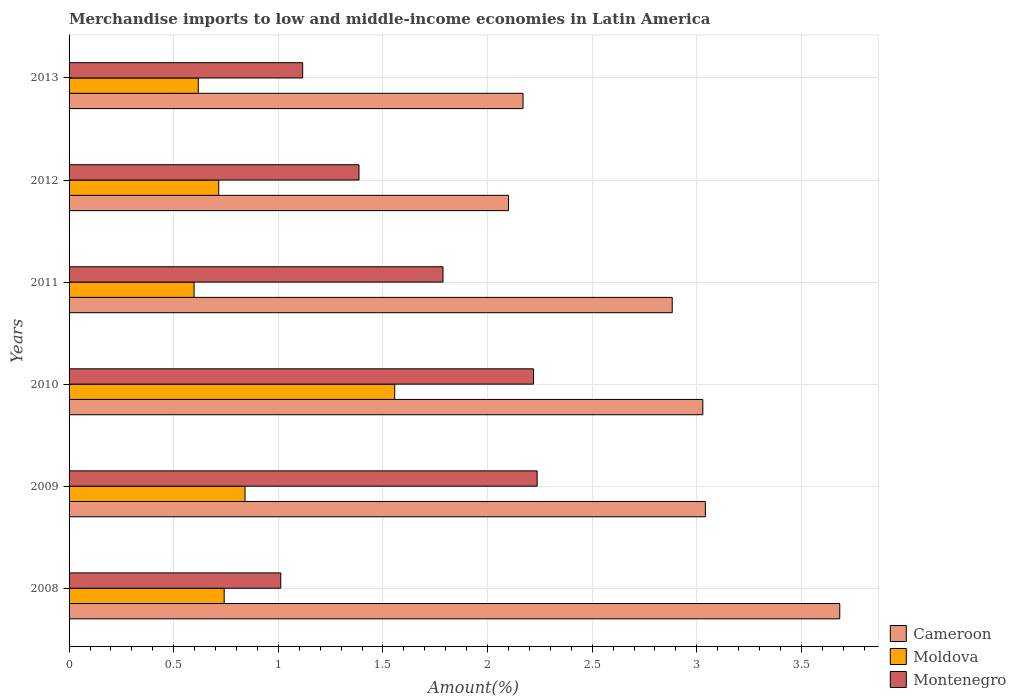How many different coloured bars are there?
Your answer should be compact. 3. How many groups of bars are there?
Ensure brevity in your answer.  6. Are the number of bars on each tick of the Y-axis equal?
Provide a succinct answer. Yes. How many bars are there on the 1st tick from the bottom?
Provide a short and direct response. 3. What is the label of the 3rd group of bars from the top?
Make the answer very short. 2011. In how many cases, is the number of bars for a given year not equal to the number of legend labels?
Your answer should be compact. 0. What is the percentage of amount earned from merchandise imports in Moldova in 2008?
Ensure brevity in your answer.  0.74. Across all years, what is the maximum percentage of amount earned from merchandise imports in Cameroon?
Make the answer very short. 3.68. Across all years, what is the minimum percentage of amount earned from merchandise imports in Montenegro?
Ensure brevity in your answer.  1.01. In which year was the percentage of amount earned from merchandise imports in Cameroon maximum?
Provide a short and direct response. 2008. What is the total percentage of amount earned from merchandise imports in Montenegro in the graph?
Keep it short and to the point. 9.76. What is the difference between the percentage of amount earned from merchandise imports in Moldova in 2011 and that in 2013?
Make the answer very short. -0.02. What is the difference between the percentage of amount earned from merchandise imports in Montenegro in 2013 and the percentage of amount earned from merchandise imports in Cameroon in 2012?
Offer a very short reply. -0.98. What is the average percentage of amount earned from merchandise imports in Moldova per year?
Your response must be concise. 0.84. In the year 2010, what is the difference between the percentage of amount earned from merchandise imports in Montenegro and percentage of amount earned from merchandise imports in Cameroon?
Provide a short and direct response. -0.81. What is the ratio of the percentage of amount earned from merchandise imports in Cameroon in 2008 to that in 2009?
Offer a very short reply. 1.21. What is the difference between the highest and the second highest percentage of amount earned from merchandise imports in Cameroon?
Make the answer very short. 0.64. What is the difference between the highest and the lowest percentage of amount earned from merchandise imports in Montenegro?
Your answer should be compact. 1.23. In how many years, is the percentage of amount earned from merchandise imports in Cameroon greater than the average percentage of amount earned from merchandise imports in Cameroon taken over all years?
Your answer should be very brief. 4. Is the sum of the percentage of amount earned from merchandise imports in Cameroon in 2009 and 2011 greater than the maximum percentage of amount earned from merchandise imports in Montenegro across all years?
Your answer should be very brief. Yes. What does the 1st bar from the top in 2012 represents?
Provide a succinct answer. Montenegro. What does the 1st bar from the bottom in 2010 represents?
Your response must be concise. Cameroon. How many bars are there?
Provide a succinct answer. 18. Are all the bars in the graph horizontal?
Provide a succinct answer. Yes. Are the values on the major ticks of X-axis written in scientific E-notation?
Make the answer very short. No. Does the graph contain any zero values?
Provide a succinct answer. No. How many legend labels are there?
Your answer should be compact. 3. What is the title of the graph?
Provide a succinct answer. Merchandise imports to low and middle-income economies in Latin America. Does "Virgin Islands" appear as one of the legend labels in the graph?
Give a very brief answer. No. What is the label or title of the X-axis?
Provide a short and direct response. Amount(%). What is the label or title of the Y-axis?
Give a very brief answer. Years. What is the Amount(%) of Cameroon in 2008?
Offer a terse response. 3.68. What is the Amount(%) of Moldova in 2008?
Provide a succinct answer. 0.74. What is the Amount(%) in Montenegro in 2008?
Your answer should be compact. 1.01. What is the Amount(%) in Cameroon in 2009?
Provide a succinct answer. 3.04. What is the Amount(%) in Moldova in 2009?
Your answer should be very brief. 0.84. What is the Amount(%) of Montenegro in 2009?
Your response must be concise. 2.24. What is the Amount(%) of Cameroon in 2010?
Provide a succinct answer. 3.03. What is the Amount(%) in Moldova in 2010?
Offer a terse response. 1.56. What is the Amount(%) of Montenegro in 2010?
Your answer should be very brief. 2.22. What is the Amount(%) of Cameroon in 2011?
Provide a short and direct response. 2.88. What is the Amount(%) in Moldova in 2011?
Offer a very short reply. 0.6. What is the Amount(%) of Montenegro in 2011?
Provide a succinct answer. 1.79. What is the Amount(%) in Cameroon in 2012?
Keep it short and to the point. 2.1. What is the Amount(%) in Moldova in 2012?
Keep it short and to the point. 0.72. What is the Amount(%) of Montenegro in 2012?
Offer a terse response. 1.39. What is the Amount(%) in Cameroon in 2013?
Provide a short and direct response. 2.17. What is the Amount(%) of Moldova in 2013?
Provide a succinct answer. 0.62. What is the Amount(%) of Montenegro in 2013?
Offer a very short reply. 1.12. Across all years, what is the maximum Amount(%) of Cameroon?
Your answer should be compact. 3.68. Across all years, what is the maximum Amount(%) in Moldova?
Offer a very short reply. 1.56. Across all years, what is the maximum Amount(%) of Montenegro?
Provide a short and direct response. 2.24. Across all years, what is the minimum Amount(%) of Cameroon?
Provide a short and direct response. 2.1. Across all years, what is the minimum Amount(%) in Moldova?
Ensure brevity in your answer.  0.6. Across all years, what is the minimum Amount(%) in Montenegro?
Make the answer very short. 1.01. What is the total Amount(%) in Cameroon in the graph?
Give a very brief answer. 16.91. What is the total Amount(%) of Moldova in the graph?
Make the answer very short. 5.07. What is the total Amount(%) of Montenegro in the graph?
Your answer should be very brief. 9.76. What is the difference between the Amount(%) of Cameroon in 2008 and that in 2009?
Provide a short and direct response. 0.64. What is the difference between the Amount(%) of Moldova in 2008 and that in 2009?
Your answer should be very brief. -0.1. What is the difference between the Amount(%) in Montenegro in 2008 and that in 2009?
Offer a very short reply. -1.23. What is the difference between the Amount(%) of Cameroon in 2008 and that in 2010?
Your answer should be compact. 0.65. What is the difference between the Amount(%) of Moldova in 2008 and that in 2010?
Your answer should be compact. -0.82. What is the difference between the Amount(%) in Montenegro in 2008 and that in 2010?
Make the answer very short. -1.21. What is the difference between the Amount(%) in Cameroon in 2008 and that in 2011?
Give a very brief answer. 0.8. What is the difference between the Amount(%) in Moldova in 2008 and that in 2011?
Offer a terse response. 0.14. What is the difference between the Amount(%) in Montenegro in 2008 and that in 2011?
Keep it short and to the point. -0.78. What is the difference between the Amount(%) in Cameroon in 2008 and that in 2012?
Your answer should be very brief. 1.58. What is the difference between the Amount(%) in Moldova in 2008 and that in 2012?
Give a very brief answer. 0.03. What is the difference between the Amount(%) in Montenegro in 2008 and that in 2012?
Your answer should be compact. -0.37. What is the difference between the Amount(%) in Cameroon in 2008 and that in 2013?
Your answer should be compact. 1.51. What is the difference between the Amount(%) of Moldova in 2008 and that in 2013?
Provide a short and direct response. 0.12. What is the difference between the Amount(%) of Montenegro in 2008 and that in 2013?
Offer a terse response. -0.1. What is the difference between the Amount(%) in Cameroon in 2009 and that in 2010?
Ensure brevity in your answer.  0.01. What is the difference between the Amount(%) in Moldova in 2009 and that in 2010?
Your answer should be compact. -0.72. What is the difference between the Amount(%) of Montenegro in 2009 and that in 2010?
Provide a short and direct response. 0.02. What is the difference between the Amount(%) of Cameroon in 2009 and that in 2011?
Your answer should be compact. 0.16. What is the difference between the Amount(%) of Moldova in 2009 and that in 2011?
Make the answer very short. 0.24. What is the difference between the Amount(%) in Montenegro in 2009 and that in 2011?
Your answer should be compact. 0.45. What is the difference between the Amount(%) of Cameroon in 2009 and that in 2012?
Your response must be concise. 0.94. What is the difference between the Amount(%) in Moldova in 2009 and that in 2012?
Provide a short and direct response. 0.13. What is the difference between the Amount(%) in Montenegro in 2009 and that in 2012?
Your answer should be very brief. 0.85. What is the difference between the Amount(%) in Cameroon in 2009 and that in 2013?
Your answer should be compact. 0.87. What is the difference between the Amount(%) in Moldova in 2009 and that in 2013?
Your answer should be compact. 0.22. What is the difference between the Amount(%) in Montenegro in 2009 and that in 2013?
Give a very brief answer. 1.12. What is the difference between the Amount(%) in Cameroon in 2010 and that in 2011?
Offer a very short reply. 0.15. What is the difference between the Amount(%) of Moldova in 2010 and that in 2011?
Your answer should be compact. 0.96. What is the difference between the Amount(%) in Montenegro in 2010 and that in 2011?
Keep it short and to the point. 0.43. What is the difference between the Amount(%) in Cameroon in 2010 and that in 2012?
Provide a succinct answer. 0.93. What is the difference between the Amount(%) in Moldova in 2010 and that in 2012?
Provide a succinct answer. 0.84. What is the difference between the Amount(%) in Montenegro in 2010 and that in 2012?
Your answer should be compact. 0.83. What is the difference between the Amount(%) in Cameroon in 2010 and that in 2013?
Provide a short and direct response. 0.86. What is the difference between the Amount(%) of Moldova in 2010 and that in 2013?
Keep it short and to the point. 0.94. What is the difference between the Amount(%) in Montenegro in 2010 and that in 2013?
Provide a short and direct response. 1.1. What is the difference between the Amount(%) of Cameroon in 2011 and that in 2012?
Offer a terse response. 0.78. What is the difference between the Amount(%) of Moldova in 2011 and that in 2012?
Make the answer very short. -0.12. What is the difference between the Amount(%) of Montenegro in 2011 and that in 2012?
Provide a succinct answer. 0.4. What is the difference between the Amount(%) of Cameroon in 2011 and that in 2013?
Provide a succinct answer. 0.71. What is the difference between the Amount(%) of Moldova in 2011 and that in 2013?
Give a very brief answer. -0.02. What is the difference between the Amount(%) in Montenegro in 2011 and that in 2013?
Provide a succinct answer. 0.67. What is the difference between the Amount(%) of Cameroon in 2012 and that in 2013?
Ensure brevity in your answer.  -0.07. What is the difference between the Amount(%) in Moldova in 2012 and that in 2013?
Provide a short and direct response. 0.1. What is the difference between the Amount(%) in Montenegro in 2012 and that in 2013?
Provide a succinct answer. 0.27. What is the difference between the Amount(%) of Cameroon in 2008 and the Amount(%) of Moldova in 2009?
Offer a terse response. 2.84. What is the difference between the Amount(%) of Cameroon in 2008 and the Amount(%) of Montenegro in 2009?
Make the answer very short. 1.45. What is the difference between the Amount(%) of Moldova in 2008 and the Amount(%) of Montenegro in 2009?
Offer a terse response. -1.5. What is the difference between the Amount(%) in Cameroon in 2008 and the Amount(%) in Moldova in 2010?
Ensure brevity in your answer.  2.13. What is the difference between the Amount(%) in Cameroon in 2008 and the Amount(%) in Montenegro in 2010?
Provide a succinct answer. 1.46. What is the difference between the Amount(%) of Moldova in 2008 and the Amount(%) of Montenegro in 2010?
Offer a terse response. -1.48. What is the difference between the Amount(%) in Cameroon in 2008 and the Amount(%) in Moldova in 2011?
Offer a very short reply. 3.09. What is the difference between the Amount(%) of Cameroon in 2008 and the Amount(%) of Montenegro in 2011?
Your answer should be very brief. 1.9. What is the difference between the Amount(%) of Moldova in 2008 and the Amount(%) of Montenegro in 2011?
Offer a very short reply. -1.05. What is the difference between the Amount(%) in Cameroon in 2008 and the Amount(%) in Moldova in 2012?
Keep it short and to the point. 2.97. What is the difference between the Amount(%) of Cameroon in 2008 and the Amount(%) of Montenegro in 2012?
Make the answer very short. 2.3. What is the difference between the Amount(%) of Moldova in 2008 and the Amount(%) of Montenegro in 2012?
Your answer should be compact. -0.64. What is the difference between the Amount(%) in Cameroon in 2008 and the Amount(%) in Moldova in 2013?
Provide a succinct answer. 3.07. What is the difference between the Amount(%) of Cameroon in 2008 and the Amount(%) of Montenegro in 2013?
Offer a very short reply. 2.57. What is the difference between the Amount(%) in Moldova in 2008 and the Amount(%) in Montenegro in 2013?
Your answer should be compact. -0.38. What is the difference between the Amount(%) of Cameroon in 2009 and the Amount(%) of Moldova in 2010?
Your response must be concise. 1.48. What is the difference between the Amount(%) in Cameroon in 2009 and the Amount(%) in Montenegro in 2010?
Your answer should be very brief. 0.82. What is the difference between the Amount(%) of Moldova in 2009 and the Amount(%) of Montenegro in 2010?
Your answer should be compact. -1.38. What is the difference between the Amount(%) of Cameroon in 2009 and the Amount(%) of Moldova in 2011?
Offer a terse response. 2.44. What is the difference between the Amount(%) of Cameroon in 2009 and the Amount(%) of Montenegro in 2011?
Make the answer very short. 1.25. What is the difference between the Amount(%) of Moldova in 2009 and the Amount(%) of Montenegro in 2011?
Give a very brief answer. -0.95. What is the difference between the Amount(%) in Cameroon in 2009 and the Amount(%) in Moldova in 2012?
Your answer should be very brief. 2.33. What is the difference between the Amount(%) of Cameroon in 2009 and the Amount(%) of Montenegro in 2012?
Your answer should be very brief. 1.66. What is the difference between the Amount(%) in Moldova in 2009 and the Amount(%) in Montenegro in 2012?
Offer a very short reply. -0.54. What is the difference between the Amount(%) in Cameroon in 2009 and the Amount(%) in Moldova in 2013?
Make the answer very short. 2.42. What is the difference between the Amount(%) in Cameroon in 2009 and the Amount(%) in Montenegro in 2013?
Your answer should be very brief. 1.92. What is the difference between the Amount(%) of Moldova in 2009 and the Amount(%) of Montenegro in 2013?
Offer a terse response. -0.28. What is the difference between the Amount(%) of Cameroon in 2010 and the Amount(%) of Moldova in 2011?
Offer a terse response. 2.43. What is the difference between the Amount(%) in Cameroon in 2010 and the Amount(%) in Montenegro in 2011?
Ensure brevity in your answer.  1.24. What is the difference between the Amount(%) of Moldova in 2010 and the Amount(%) of Montenegro in 2011?
Give a very brief answer. -0.23. What is the difference between the Amount(%) of Cameroon in 2010 and the Amount(%) of Moldova in 2012?
Ensure brevity in your answer.  2.31. What is the difference between the Amount(%) in Cameroon in 2010 and the Amount(%) in Montenegro in 2012?
Offer a very short reply. 1.64. What is the difference between the Amount(%) of Moldova in 2010 and the Amount(%) of Montenegro in 2012?
Offer a terse response. 0.17. What is the difference between the Amount(%) of Cameroon in 2010 and the Amount(%) of Moldova in 2013?
Provide a succinct answer. 2.41. What is the difference between the Amount(%) of Cameroon in 2010 and the Amount(%) of Montenegro in 2013?
Ensure brevity in your answer.  1.91. What is the difference between the Amount(%) in Moldova in 2010 and the Amount(%) in Montenegro in 2013?
Provide a succinct answer. 0.44. What is the difference between the Amount(%) in Cameroon in 2011 and the Amount(%) in Moldova in 2012?
Give a very brief answer. 2.17. What is the difference between the Amount(%) of Cameroon in 2011 and the Amount(%) of Montenegro in 2012?
Ensure brevity in your answer.  1.5. What is the difference between the Amount(%) in Moldova in 2011 and the Amount(%) in Montenegro in 2012?
Your response must be concise. -0.79. What is the difference between the Amount(%) of Cameroon in 2011 and the Amount(%) of Moldova in 2013?
Your answer should be compact. 2.27. What is the difference between the Amount(%) in Cameroon in 2011 and the Amount(%) in Montenegro in 2013?
Your answer should be very brief. 1.77. What is the difference between the Amount(%) of Moldova in 2011 and the Amount(%) of Montenegro in 2013?
Provide a short and direct response. -0.52. What is the difference between the Amount(%) in Cameroon in 2012 and the Amount(%) in Moldova in 2013?
Provide a succinct answer. 1.48. What is the difference between the Amount(%) of Cameroon in 2012 and the Amount(%) of Montenegro in 2013?
Make the answer very short. 0.98. What is the difference between the Amount(%) in Moldova in 2012 and the Amount(%) in Montenegro in 2013?
Offer a terse response. -0.4. What is the average Amount(%) in Cameroon per year?
Offer a very short reply. 2.82. What is the average Amount(%) of Moldova per year?
Keep it short and to the point. 0.84. What is the average Amount(%) in Montenegro per year?
Your response must be concise. 1.63. In the year 2008, what is the difference between the Amount(%) of Cameroon and Amount(%) of Moldova?
Your answer should be very brief. 2.94. In the year 2008, what is the difference between the Amount(%) in Cameroon and Amount(%) in Montenegro?
Your answer should be very brief. 2.67. In the year 2008, what is the difference between the Amount(%) in Moldova and Amount(%) in Montenegro?
Your answer should be compact. -0.27. In the year 2009, what is the difference between the Amount(%) of Cameroon and Amount(%) of Moldova?
Provide a short and direct response. 2.2. In the year 2009, what is the difference between the Amount(%) of Cameroon and Amount(%) of Montenegro?
Your response must be concise. 0.8. In the year 2009, what is the difference between the Amount(%) in Moldova and Amount(%) in Montenegro?
Make the answer very short. -1.4. In the year 2010, what is the difference between the Amount(%) of Cameroon and Amount(%) of Moldova?
Keep it short and to the point. 1.47. In the year 2010, what is the difference between the Amount(%) in Cameroon and Amount(%) in Montenegro?
Provide a short and direct response. 0.81. In the year 2010, what is the difference between the Amount(%) in Moldova and Amount(%) in Montenegro?
Provide a short and direct response. -0.66. In the year 2011, what is the difference between the Amount(%) in Cameroon and Amount(%) in Moldova?
Offer a terse response. 2.29. In the year 2011, what is the difference between the Amount(%) of Cameroon and Amount(%) of Montenegro?
Ensure brevity in your answer.  1.1. In the year 2011, what is the difference between the Amount(%) of Moldova and Amount(%) of Montenegro?
Ensure brevity in your answer.  -1.19. In the year 2012, what is the difference between the Amount(%) of Cameroon and Amount(%) of Moldova?
Make the answer very short. 1.39. In the year 2012, what is the difference between the Amount(%) of Cameroon and Amount(%) of Montenegro?
Offer a very short reply. 0.71. In the year 2012, what is the difference between the Amount(%) of Moldova and Amount(%) of Montenegro?
Provide a short and direct response. -0.67. In the year 2013, what is the difference between the Amount(%) in Cameroon and Amount(%) in Moldova?
Give a very brief answer. 1.55. In the year 2013, what is the difference between the Amount(%) in Cameroon and Amount(%) in Montenegro?
Provide a succinct answer. 1.05. In the year 2013, what is the difference between the Amount(%) of Moldova and Amount(%) of Montenegro?
Your answer should be very brief. -0.5. What is the ratio of the Amount(%) in Cameroon in 2008 to that in 2009?
Give a very brief answer. 1.21. What is the ratio of the Amount(%) of Moldova in 2008 to that in 2009?
Keep it short and to the point. 0.88. What is the ratio of the Amount(%) of Montenegro in 2008 to that in 2009?
Ensure brevity in your answer.  0.45. What is the ratio of the Amount(%) of Cameroon in 2008 to that in 2010?
Ensure brevity in your answer.  1.22. What is the ratio of the Amount(%) in Moldova in 2008 to that in 2010?
Keep it short and to the point. 0.48. What is the ratio of the Amount(%) in Montenegro in 2008 to that in 2010?
Give a very brief answer. 0.46. What is the ratio of the Amount(%) in Cameroon in 2008 to that in 2011?
Provide a succinct answer. 1.28. What is the ratio of the Amount(%) in Moldova in 2008 to that in 2011?
Give a very brief answer. 1.24. What is the ratio of the Amount(%) of Montenegro in 2008 to that in 2011?
Offer a very short reply. 0.57. What is the ratio of the Amount(%) of Cameroon in 2008 to that in 2012?
Offer a terse response. 1.75. What is the ratio of the Amount(%) of Moldova in 2008 to that in 2012?
Give a very brief answer. 1.04. What is the ratio of the Amount(%) in Montenegro in 2008 to that in 2012?
Offer a terse response. 0.73. What is the ratio of the Amount(%) in Cameroon in 2008 to that in 2013?
Make the answer very short. 1.7. What is the ratio of the Amount(%) of Moldova in 2008 to that in 2013?
Offer a terse response. 1.2. What is the ratio of the Amount(%) in Montenegro in 2008 to that in 2013?
Offer a very short reply. 0.91. What is the ratio of the Amount(%) in Cameroon in 2009 to that in 2010?
Ensure brevity in your answer.  1. What is the ratio of the Amount(%) in Moldova in 2009 to that in 2010?
Give a very brief answer. 0.54. What is the ratio of the Amount(%) in Montenegro in 2009 to that in 2010?
Your answer should be compact. 1.01. What is the ratio of the Amount(%) of Cameroon in 2009 to that in 2011?
Your response must be concise. 1.05. What is the ratio of the Amount(%) in Moldova in 2009 to that in 2011?
Give a very brief answer. 1.41. What is the ratio of the Amount(%) in Montenegro in 2009 to that in 2011?
Provide a succinct answer. 1.25. What is the ratio of the Amount(%) in Cameroon in 2009 to that in 2012?
Keep it short and to the point. 1.45. What is the ratio of the Amount(%) in Moldova in 2009 to that in 2012?
Make the answer very short. 1.18. What is the ratio of the Amount(%) of Montenegro in 2009 to that in 2012?
Make the answer very short. 1.61. What is the ratio of the Amount(%) in Cameroon in 2009 to that in 2013?
Offer a very short reply. 1.4. What is the ratio of the Amount(%) in Moldova in 2009 to that in 2013?
Give a very brief answer. 1.36. What is the ratio of the Amount(%) in Montenegro in 2009 to that in 2013?
Provide a succinct answer. 2. What is the ratio of the Amount(%) of Cameroon in 2010 to that in 2011?
Ensure brevity in your answer.  1.05. What is the ratio of the Amount(%) of Moldova in 2010 to that in 2011?
Offer a terse response. 2.61. What is the ratio of the Amount(%) in Montenegro in 2010 to that in 2011?
Your response must be concise. 1.24. What is the ratio of the Amount(%) of Cameroon in 2010 to that in 2012?
Provide a succinct answer. 1.44. What is the ratio of the Amount(%) of Moldova in 2010 to that in 2012?
Offer a terse response. 2.18. What is the ratio of the Amount(%) of Montenegro in 2010 to that in 2012?
Offer a very short reply. 1.6. What is the ratio of the Amount(%) of Cameroon in 2010 to that in 2013?
Your answer should be compact. 1.4. What is the ratio of the Amount(%) in Moldova in 2010 to that in 2013?
Your answer should be compact. 2.52. What is the ratio of the Amount(%) in Montenegro in 2010 to that in 2013?
Keep it short and to the point. 1.99. What is the ratio of the Amount(%) in Cameroon in 2011 to that in 2012?
Provide a short and direct response. 1.37. What is the ratio of the Amount(%) in Moldova in 2011 to that in 2012?
Provide a succinct answer. 0.84. What is the ratio of the Amount(%) in Montenegro in 2011 to that in 2012?
Give a very brief answer. 1.29. What is the ratio of the Amount(%) in Cameroon in 2011 to that in 2013?
Keep it short and to the point. 1.33. What is the ratio of the Amount(%) of Moldova in 2011 to that in 2013?
Your answer should be very brief. 0.97. What is the ratio of the Amount(%) in Montenegro in 2011 to that in 2013?
Provide a short and direct response. 1.6. What is the ratio of the Amount(%) in Cameroon in 2012 to that in 2013?
Offer a terse response. 0.97. What is the ratio of the Amount(%) of Moldova in 2012 to that in 2013?
Your response must be concise. 1.16. What is the ratio of the Amount(%) in Montenegro in 2012 to that in 2013?
Make the answer very short. 1.24. What is the difference between the highest and the second highest Amount(%) in Cameroon?
Offer a very short reply. 0.64. What is the difference between the highest and the second highest Amount(%) in Moldova?
Give a very brief answer. 0.72. What is the difference between the highest and the second highest Amount(%) in Montenegro?
Keep it short and to the point. 0.02. What is the difference between the highest and the lowest Amount(%) of Cameroon?
Make the answer very short. 1.58. What is the difference between the highest and the lowest Amount(%) in Moldova?
Your answer should be very brief. 0.96. What is the difference between the highest and the lowest Amount(%) in Montenegro?
Offer a terse response. 1.23. 